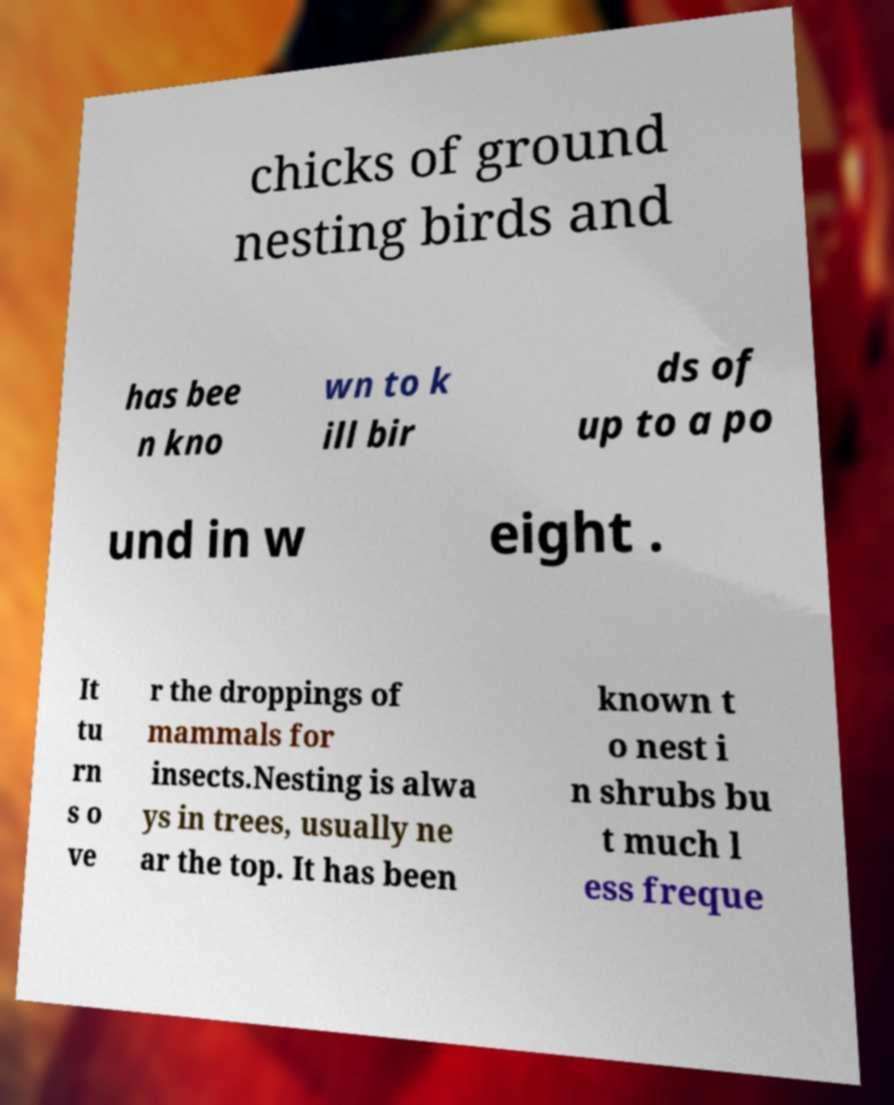Please read and relay the text visible in this image. What does it say? chicks of ground nesting birds and has bee n kno wn to k ill bir ds of up to a po und in w eight . It tu rn s o ve r the droppings of mammals for insects.Nesting is alwa ys in trees, usually ne ar the top. It has been known t o nest i n shrubs bu t much l ess freque 